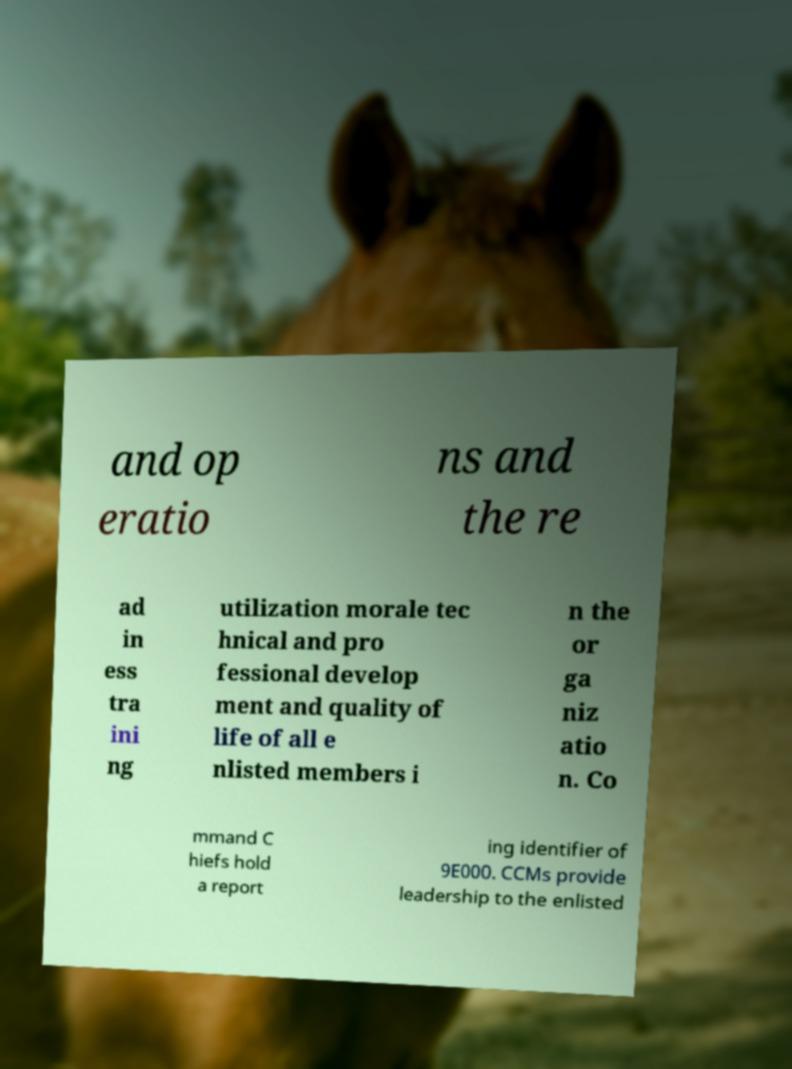I need the written content from this picture converted into text. Can you do that? and op eratio ns and the re ad in ess tra ini ng utilization morale tec hnical and pro fessional develop ment and quality of life of all e nlisted members i n the or ga niz atio n. Co mmand C hiefs hold a report ing identifier of 9E000. CCMs provide leadership to the enlisted 